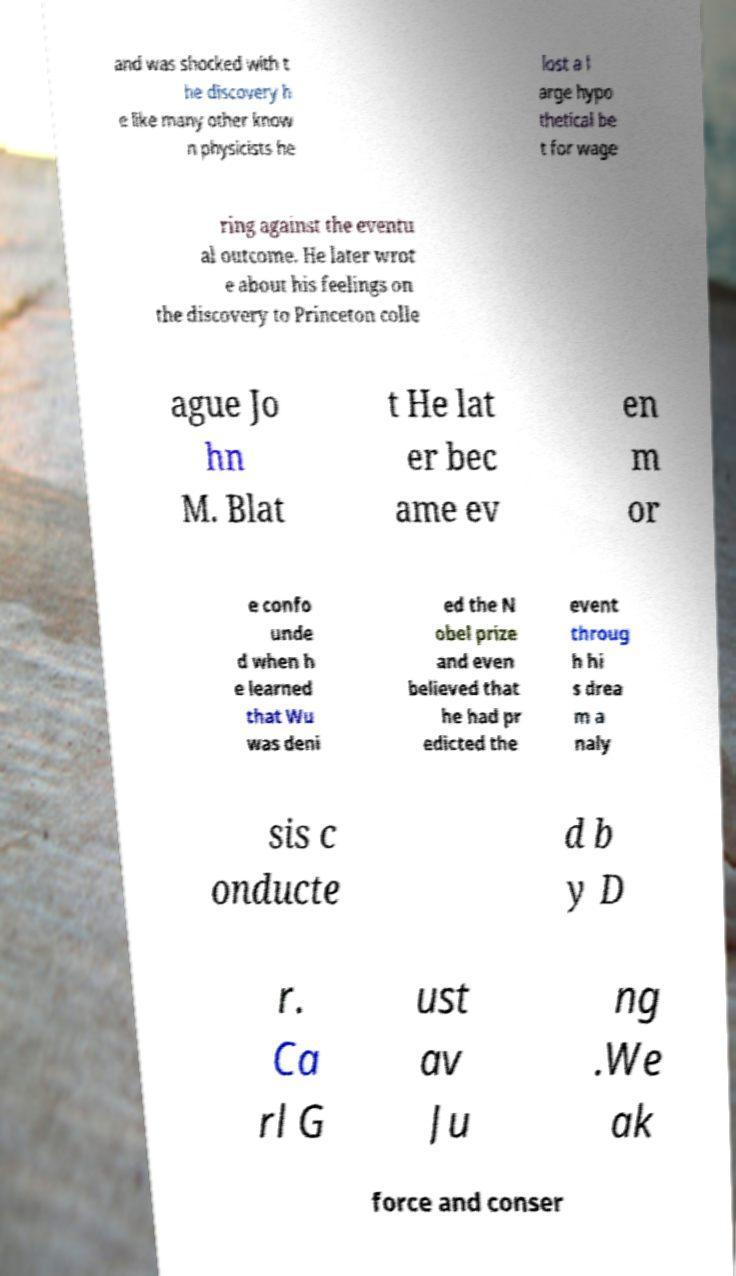Could you assist in decoding the text presented in this image and type it out clearly? and was shocked with t he discovery h e like many other know n physicists he lost a l arge hypo thetical be t for wage ring against the eventu al outcome. He later wrot e about his feelings on the discovery to Princeton colle ague Jo hn M. Blat t He lat er bec ame ev en m or e confo unde d when h e learned that Wu was deni ed the N obel prize and even believed that he had pr edicted the event throug h hi s drea m a naly sis c onducte d b y D r. Ca rl G ust av Ju ng .We ak force and conser 